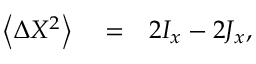Convert formula to latex. <formula><loc_0><loc_0><loc_500><loc_500>\begin{array} { r l r } { \left \langle \Delta X ^ { 2 } \right \rangle } & = } & { 2 I _ { x } - 2 J _ { x } , } \end{array}</formula> 